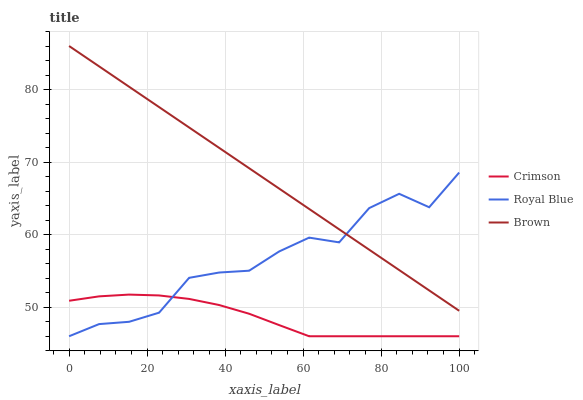Does Crimson have the minimum area under the curve?
Answer yes or no. Yes. Does Brown have the maximum area under the curve?
Answer yes or no. Yes. Does Royal Blue have the minimum area under the curve?
Answer yes or no. No. Does Royal Blue have the maximum area under the curve?
Answer yes or no. No. Is Brown the smoothest?
Answer yes or no. Yes. Is Royal Blue the roughest?
Answer yes or no. Yes. Is Royal Blue the smoothest?
Answer yes or no. No. Is Brown the roughest?
Answer yes or no. No. Does Crimson have the lowest value?
Answer yes or no. Yes. Does Brown have the lowest value?
Answer yes or no. No. Does Brown have the highest value?
Answer yes or no. Yes. Does Royal Blue have the highest value?
Answer yes or no. No. Is Crimson less than Brown?
Answer yes or no. Yes. Is Brown greater than Crimson?
Answer yes or no. Yes. Does Royal Blue intersect Crimson?
Answer yes or no. Yes. Is Royal Blue less than Crimson?
Answer yes or no. No. Is Royal Blue greater than Crimson?
Answer yes or no. No. Does Crimson intersect Brown?
Answer yes or no. No. 